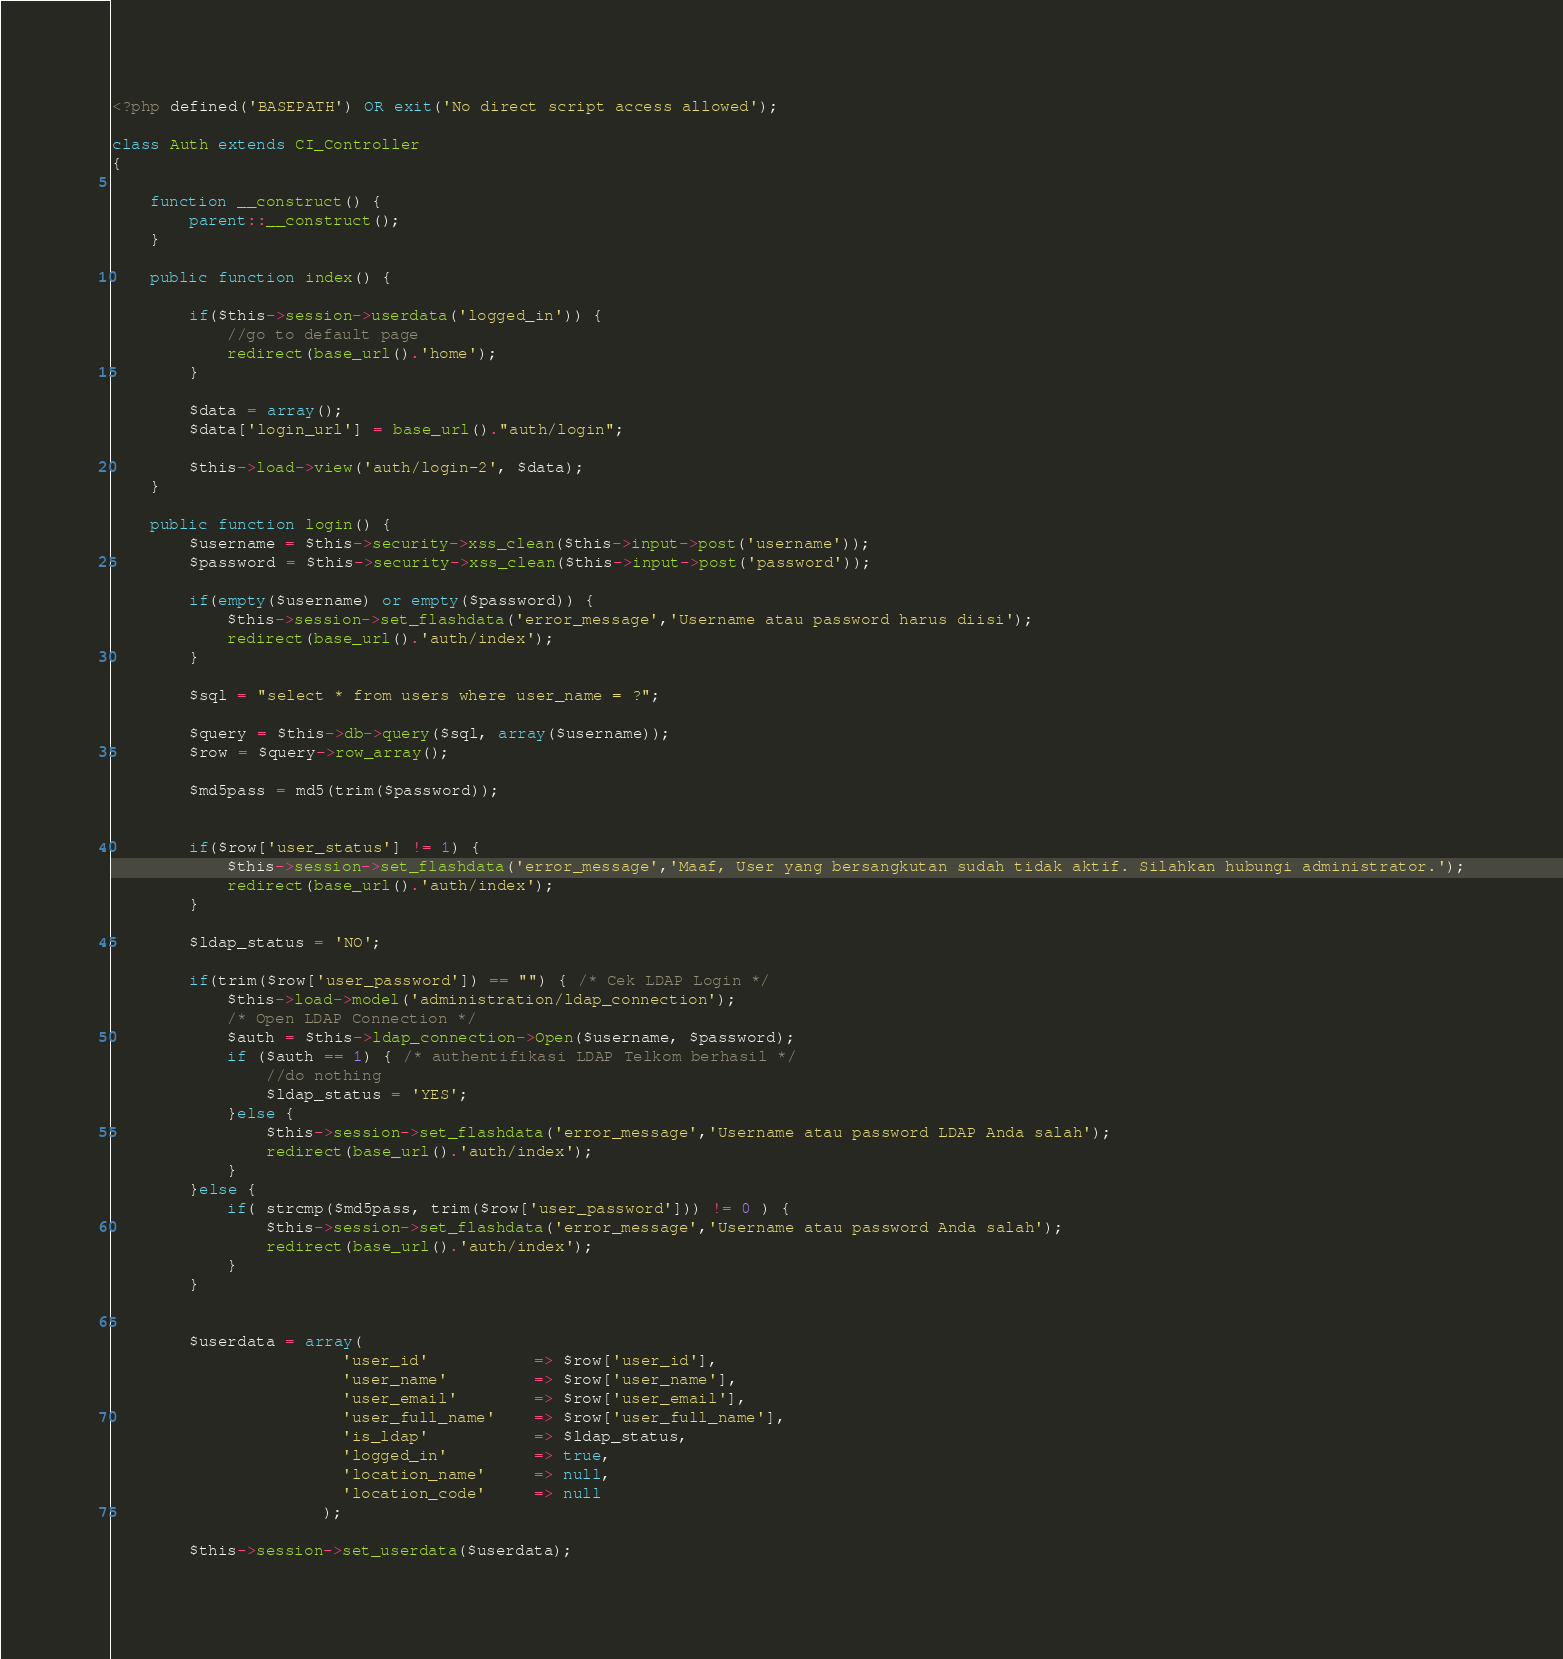<code> <loc_0><loc_0><loc_500><loc_500><_PHP_><?php defined('BASEPATH') OR exit('No direct script access allowed');

class Auth extends CI_Controller
{

    function __construct() {
        parent::__construct();
    }

    public function index() {

        if($this->session->userdata('logged_in')) {
            //go to default page
            redirect(base_url().'home');
        }

        $data = array();
        $data['login_url'] = base_url()."auth/login";

        $this->load->view('auth/login-2', $data);
    }

    public function login() {
        $username = $this->security->xss_clean($this->input->post('username'));
        $password = $this->security->xss_clean($this->input->post('password'));

        if(empty($username) or empty($password)) {
            $this->session->set_flashdata('error_message','Username atau password harus diisi');
            redirect(base_url().'auth/index');
        }

        $sql = "select * from users where user_name = ?";

        $query = $this->db->query($sql, array($username));        
        $row = $query->row_array();
        
        $md5pass = md5(trim($password));


        if($row['user_status'] != 1) {
            $this->session->set_flashdata('error_message','Maaf, User yang bersangkutan sudah tidak aktif. Silahkan hubungi administrator.');
            redirect(base_url().'auth/index');
        }

        $ldap_status = 'NO';

        if(trim($row['user_password']) == "") { /* Cek LDAP Login */
            $this->load->model('administration/ldap_connection');
            /* Open LDAP Connection */
            $auth = $this->ldap_connection->Open($username, $password);
            if ($auth == 1) { /* authentifikasi LDAP Telkom berhasil */
                //do nothing
                $ldap_status = 'YES';
            }else {
                $this->session->set_flashdata('error_message','Username atau password LDAP Anda salah');
                redirect(base_url().'auth/index');
            }
        }else {
            if( strcmp($md5pass, trim($row['user_password'])) != 0 ) {
                $this->session->set_flashdata('error_message','Username atau password Anda salah');
                redirect(base_url().'auth/index');
            }
        }


        $userdata = array(
                        'user_id'           => $row['user_id'],
                        'user_name'         => $row['user_name'],
                        'user_email'        => $row['user_email'],
                        'user_full_name'    => $row['user_full_name'],
                        'is_ldap'           => $ldap_status,
                        'logged_in'         => true,
                        'location_name'     => null,
                        'location_code'     => null
                      );

        $this->session->set_userdata($userdata);</code> 